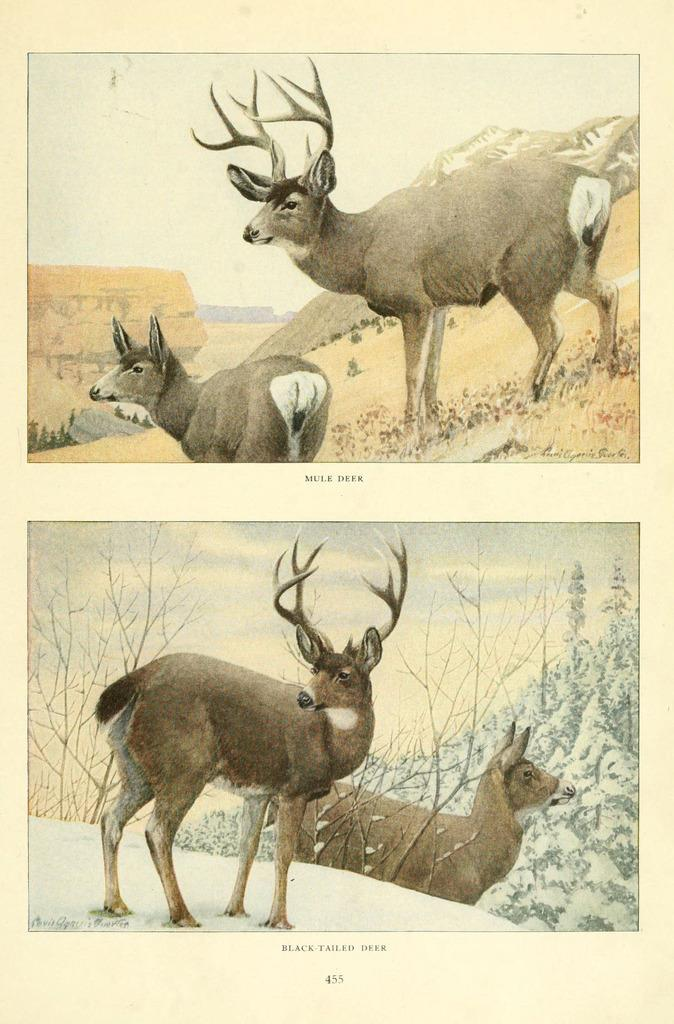What types of living organisms are present in the image? The image contains animals. What natural elements can be seen in the image? The image contains trees, mountains, and snow. What part of the natural environment is visible in the image? The sky is visible in the image. What additional information is provided below the image? There is text below the image. What type of meal is being served in the image? There is no meal present in the image; it contains animals, trees, mountains, snow, and text. Can you describe the sea visible in the image? There is no sea present in the image; it contains animals, trees, mountains, snow, and text. 